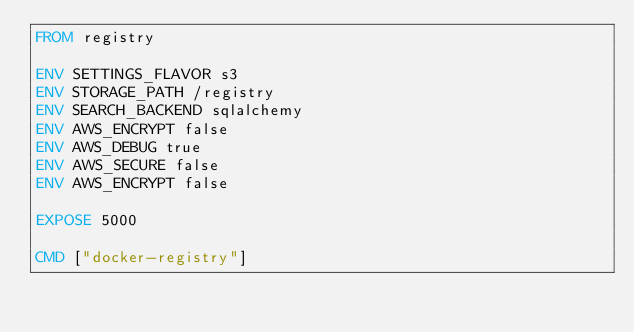Convert code to text. <code><loc_0><loc_0><loc_500><loc_500><_Dockerfile_>FROM registry

ENV SETTINGS_FLAVOR s3
ENV STORAGE_PATH /registry
ENV SEARCH_BACKEND sqlalchemy
ENV AWS_ENCRYPT false
ENV AWS_DEBUG true 
ENV AWS_SECURE false
ENV AWS_ENCRYPT false

EXPOSE 5000

CMD ["docker-registry"]
</code> 